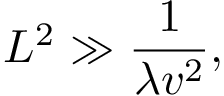<formula> <loc_0><loc_0><loc_500><loc_500>L ^ { 2 } \gg \frac { 1 } { \lambda v ^ { 2 } } ,</formula> 